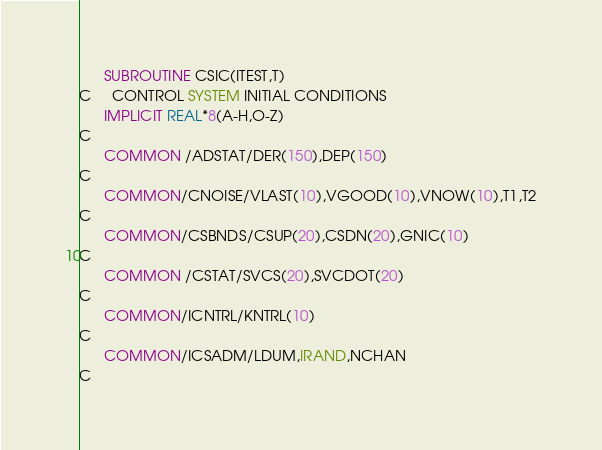<code> <loc_0><loc_0><loc_500><loc_500><_FORTRAN_>      SUBROUTINE CSIC(ITEST,T)
C     CONTROL SYSTEM INITIAL CONDITIONS
      IMPLICIT REAL*8(A-H,O-Z)
C
      COMMON /ADSTAT/DER(150),DEP(150)
C
      COMMON/CNOISE/VLAST(10),VGOOD(10),VNOW(10),T1,T2
C
      COMMON/CSBNDS/CSUP(20),CSDN(20),GNIC(10)
C
      COMMON /CSTAT/SVCS(20),SVCDOT(20)
C
      COMMON/ICNTRL/KNTRL(10)
C
      COMMON/ICSADM/LDUM,IRAND,NCHAN
C</code> 